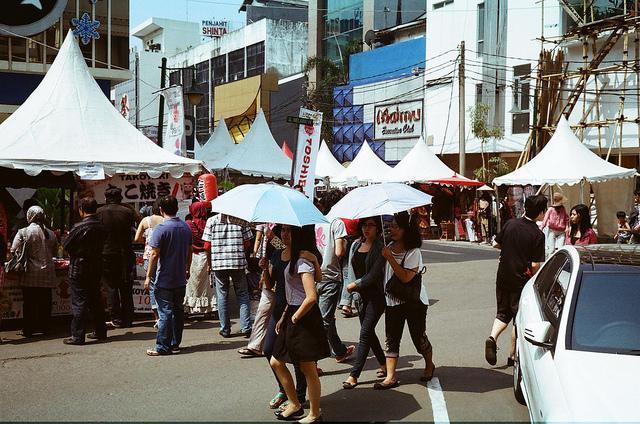How many people can you see?
Give a very brief answer. 11. How many umbrellas can be seen?
Give a very brief answer. 5. How many birds are in the photo?
Give a very brief answer. 0. 